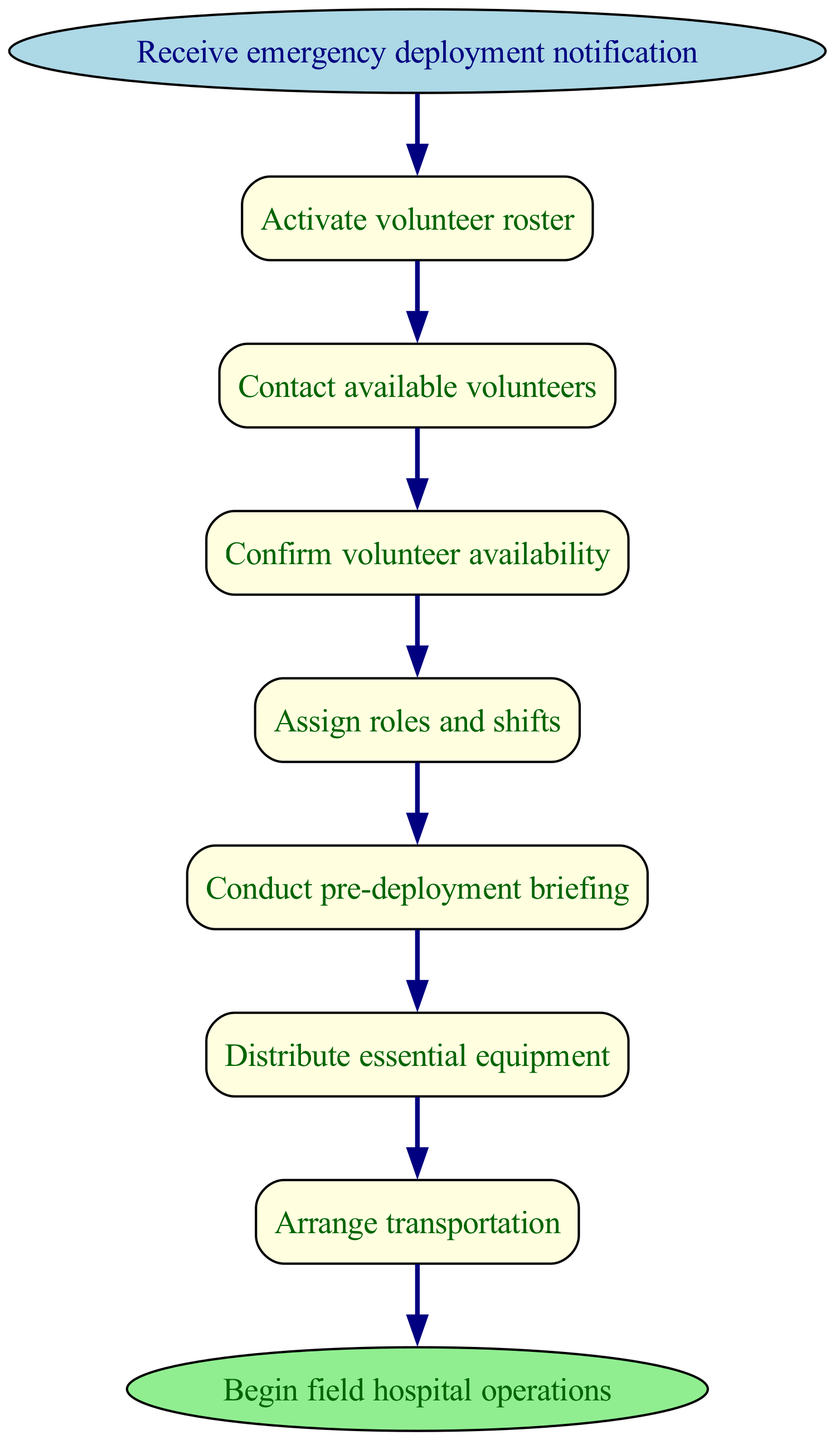What is the first step in the deployment procedure? The diagram clearly shows that the first step in the deployment procedure is "Activate volunteer roster," which is directly connected to the start node.
Answer: Activate volunteer roster How many steps are there in total? Counting all the nodes in the steps section of the diagram, there are seven distinct steps before reaching the end node.
Answer: 7 What follows after "Contact available volunteers"? The flow chart depicts an arrow leading from the "Contact available volunteers" step to the next step, which is "Confirm volunteer availability." This shows the direct relationship between these two steps.
Answer: Confirm volunteer availability What is the last action taken before beginning field hospital operations? The last node before reaching the end is "Arrange transportation," which indicates the final action that leads to the operations beginning.
Answer: Arrange transportation What relationship exists between "Conduct pre-deployment briefing" and "Distribute essential equipment"? The diagram illustrates a sequential flow with an arrow leading from "Conduct pre-deployment briefing" to "Distribute essential equipment," indicating that the former is required before the latter can occur.
Answer: Sequential flow What is the status of volunteers after "Assign roles and shifts"? According to the diagram, the action of "Assign roles and shifts" is followed by conducting a "Conduct pre-deployment briefing," implying that volunteer roles are confirmed and ready for deployment thereafter.
Answer: Ready for deployment Which step is directly connected to the start of the procedure? The specific step directly connected to the start of the procedure is "Activate volunteer roster," as it is the first action taken immediately after the emergency deployment notification is received.
Answer: Activate volunteer roster What action directly leads to deployment? The step that directly leads to deployment is "Arrange transportation," as indicated by the arrow showing its connection to "Deploy to field hospital site."
Answer: Arrange transportation 